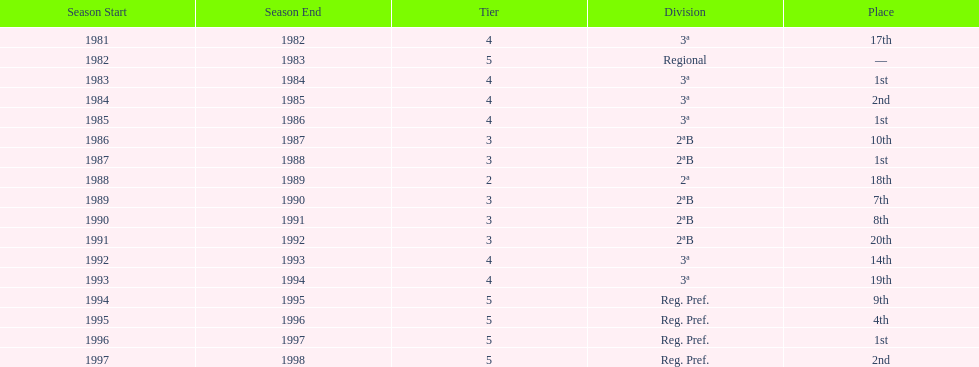Can you give me this table as a dict? {'header': ['Season Start', 'Season End', 'Tier', 'Division', 'Place'], 'rows': [['1981', '1982', '4', '3ª', '17th'], ['1982', '1983', '5', 'Regional', '—'], ['1983', '1984', '4', '3ª', '1st'], ['1984', '1985', '4', '3ª', '2nd'], ['1985', '1986', '4', '3ª', '1st'], ['1986', '1987', '3', '2ªB', '10th'], ['1987', '1988', '3', '2ªB', '1st'], ['1988', '1989', '2', '2ª', '18th'], ['1989', '1990', '3', '2ªB', '7th'], ['1990', '1991', '3', '2ªB', '8th'], ['1991', '1992', '3', '2ªB', '20th'], ['1992', '1993', '4', '3ª', '14th'], ['1993', '1994', '4', '3ª', '19th'], ['1994', '1995', '5', 'Reg. Pref.', '9th'], ['1995', '1996', '5', 'Reg. Pref.', '4th'], ['1996', '1997', '5', 'Reg. Pref.', '1st'], ['1997', '1998', '5', 'Reg. Pref.', '2nd']]} How many years were they in tier 3 5. 